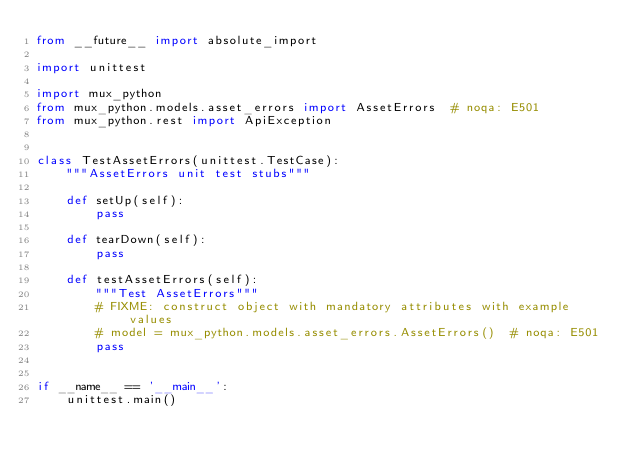Convert code to text. <code><loc_0><loc_0><loc_500><loc_500><_Python_>from __future__ import absolute_import

import unittest

import mux_python
from mux_python.models.asset_errors import AssetErrors  # noqa: E501
from mux_python.rest import ApiException


class TestAssetErrors(unittest.TestCase):
    """AssetErrors unit test stubs"""

    def setUp(self):
        pass

    def tearDown(self):
        pass

    def testAssetErrors(self):
        """Test AssetErrors"""
        # FIXME: construct object with mandatory attributes with example values
        # model = mux_python.models.asset_errors.AssetErrors()  # noqa: E501
        pass


if __name__ == '__main__':
    unittest.main()
</code> 